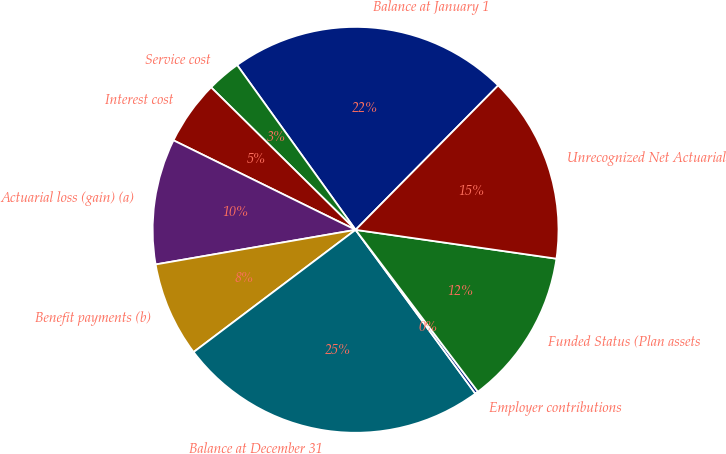Convert chart. <chart><loc_0><loc_0><loc_500><loc_500><pie_chart><fcel>Balance at January 1<fcel>Service cost<fcel>Interest cost<fcel>Actuarial loss (gain) (a)<fcel>Benefit payments (b)<fcel>Balance at December 31<fcel>Employer contributions<fcel>Funded Status (Plan assets<fcel>Unrecognized Net Actuarial<nl><fcel>22.32%<fcel>2.69%<fcel>5.12%<fcel>10.0%<fcel>7.56%<fcel>24.76%<fcel>0.25%<fcel>12.43%<fcel>14.87%<nl></chart> 